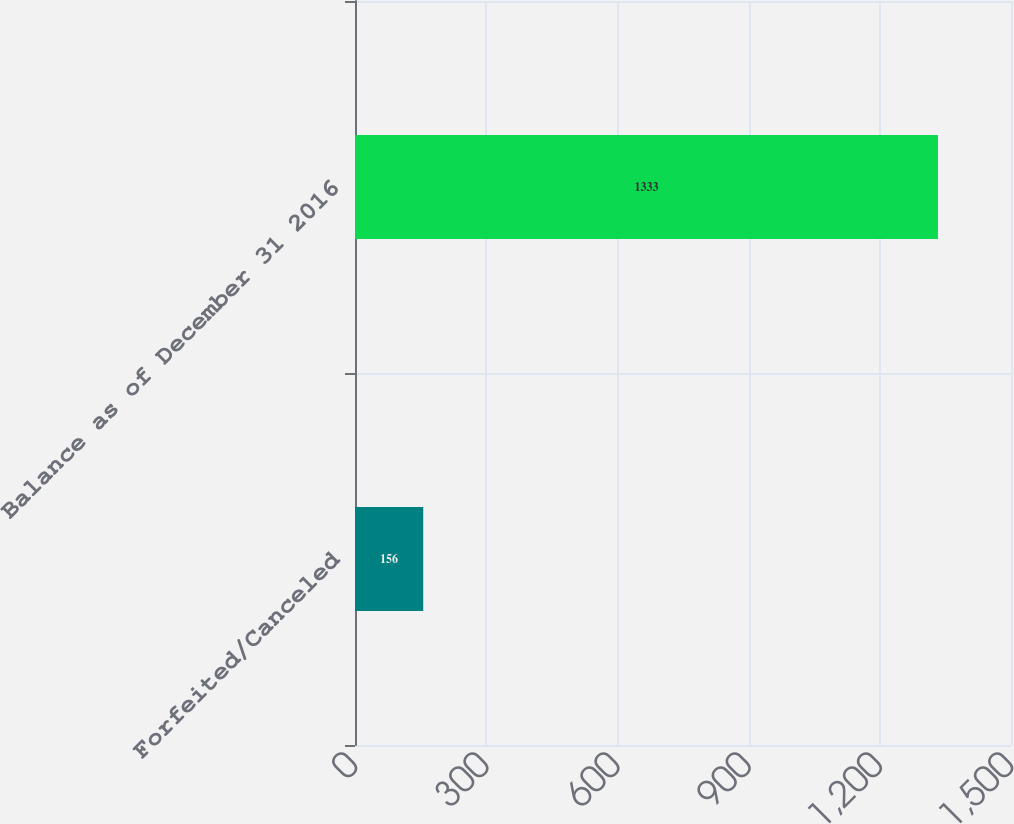<chart> <loc_0><loc_0><loc_500><loc_500><bar_chart><fcel>Forfeited/Canceled<fcel>Balance as of December 31 2016<nl><fcel>156<fcel>1333<nl></chart> 